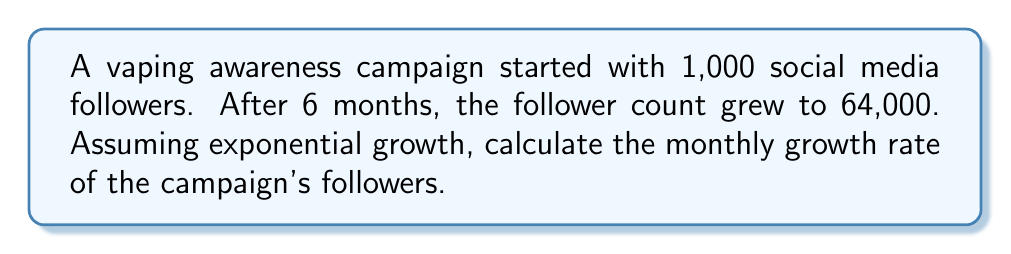Help me with this question. Let's approach this step-by-step:

1) The exponential growth formula is:
   $$A = P(1 + r)^t$$
   Where:
   $A$ = Final amount
   $P$ = Initial amount
   $r$ = Growth rate (per time period)
   $t$ = Number of time periods

2) We know:
   $P = 1,000$ (initial followers)
   $A = 64,000$ (final followers)
   $t = 6$ (months)

3) Let's plug these into our formula:
   $$64,000 = 1,000(1 + r)^6$$

4) Divide both sides by 1,000:
   $$64 = (1 + r)^6$$

5) Take the 6th root of both sides:
   $$\sqrt[6]{64} = 1 + r$$

6) Simplify:
   $$2 = 1 + r$$

7) Subtract 1 from both sides:
   $$r = 1$$

8) Convert to a percentage:
   $$r = 100\%$$

This means the follower count doubled each month.
Answer: 100% per month 